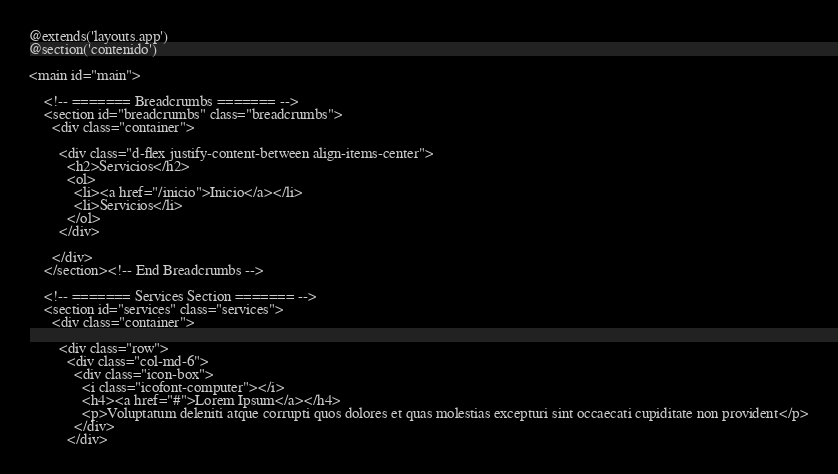Convert code to text. <code><loc_0><loc_0><loc_500><loc_500><_PHP_>@extends('layouts.app')
@section('contenido')

<main id="main">

    <!-- ======= Breadcrumbs ======= -->
    <section id="breadcrumbs" class="breadcrumbs">
      <div class="container">

        <div class="d-flex justify-content-between align-items-center">
          <h2>Servicios</h2>
          <ol>
            <li><a href="/inicio">Inicio</a></li>
            <li>Servicios</li>
          </ol>
        </div>

      </div>
    </section><!-- End Breadcrumbs -->

    <!-- ======= Services Section ======= -->
    <section id="services" class="services">
      <div class="container">

        <div class="row">
          <div class="col-md-6">
            <div class="icon-box">
              <i class="icofont-computer"></i>
              <h4><a href="#">Lorem Ipsum</a></h4>
              <p>Voluptatum deleniti atque corrupti quos dolores et quas molestias excepturi sint occaecati cupiditate non provident</p>
            </div>
          </div></code> 